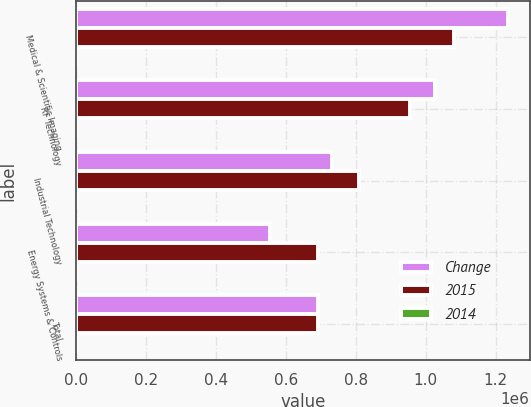<chart> <loc_0><loc_0><loc_500><loc_500><stacked_bar_chart><ecel><fcel>Medical & Scientific Imaging<fcel>RF Technology<fcel>Industrial Technology<fcel>Energy Systems & Controls<fcel>Total<nl><fcel>Change<fcel>1.23514e+06<fcel>1.025e+06<fcel>731810<fcel>555672<fcel>692136<nl><fcel>2015<fcel>1.08119e+06<fcel>955831<fcel>808921<fcel>692136<fcel>692136<nl><fcel>2014<fcel>14.2<fcel>7.2<fcel>9.5<fcel>19.7<fcel>0.3<nl></chart> 